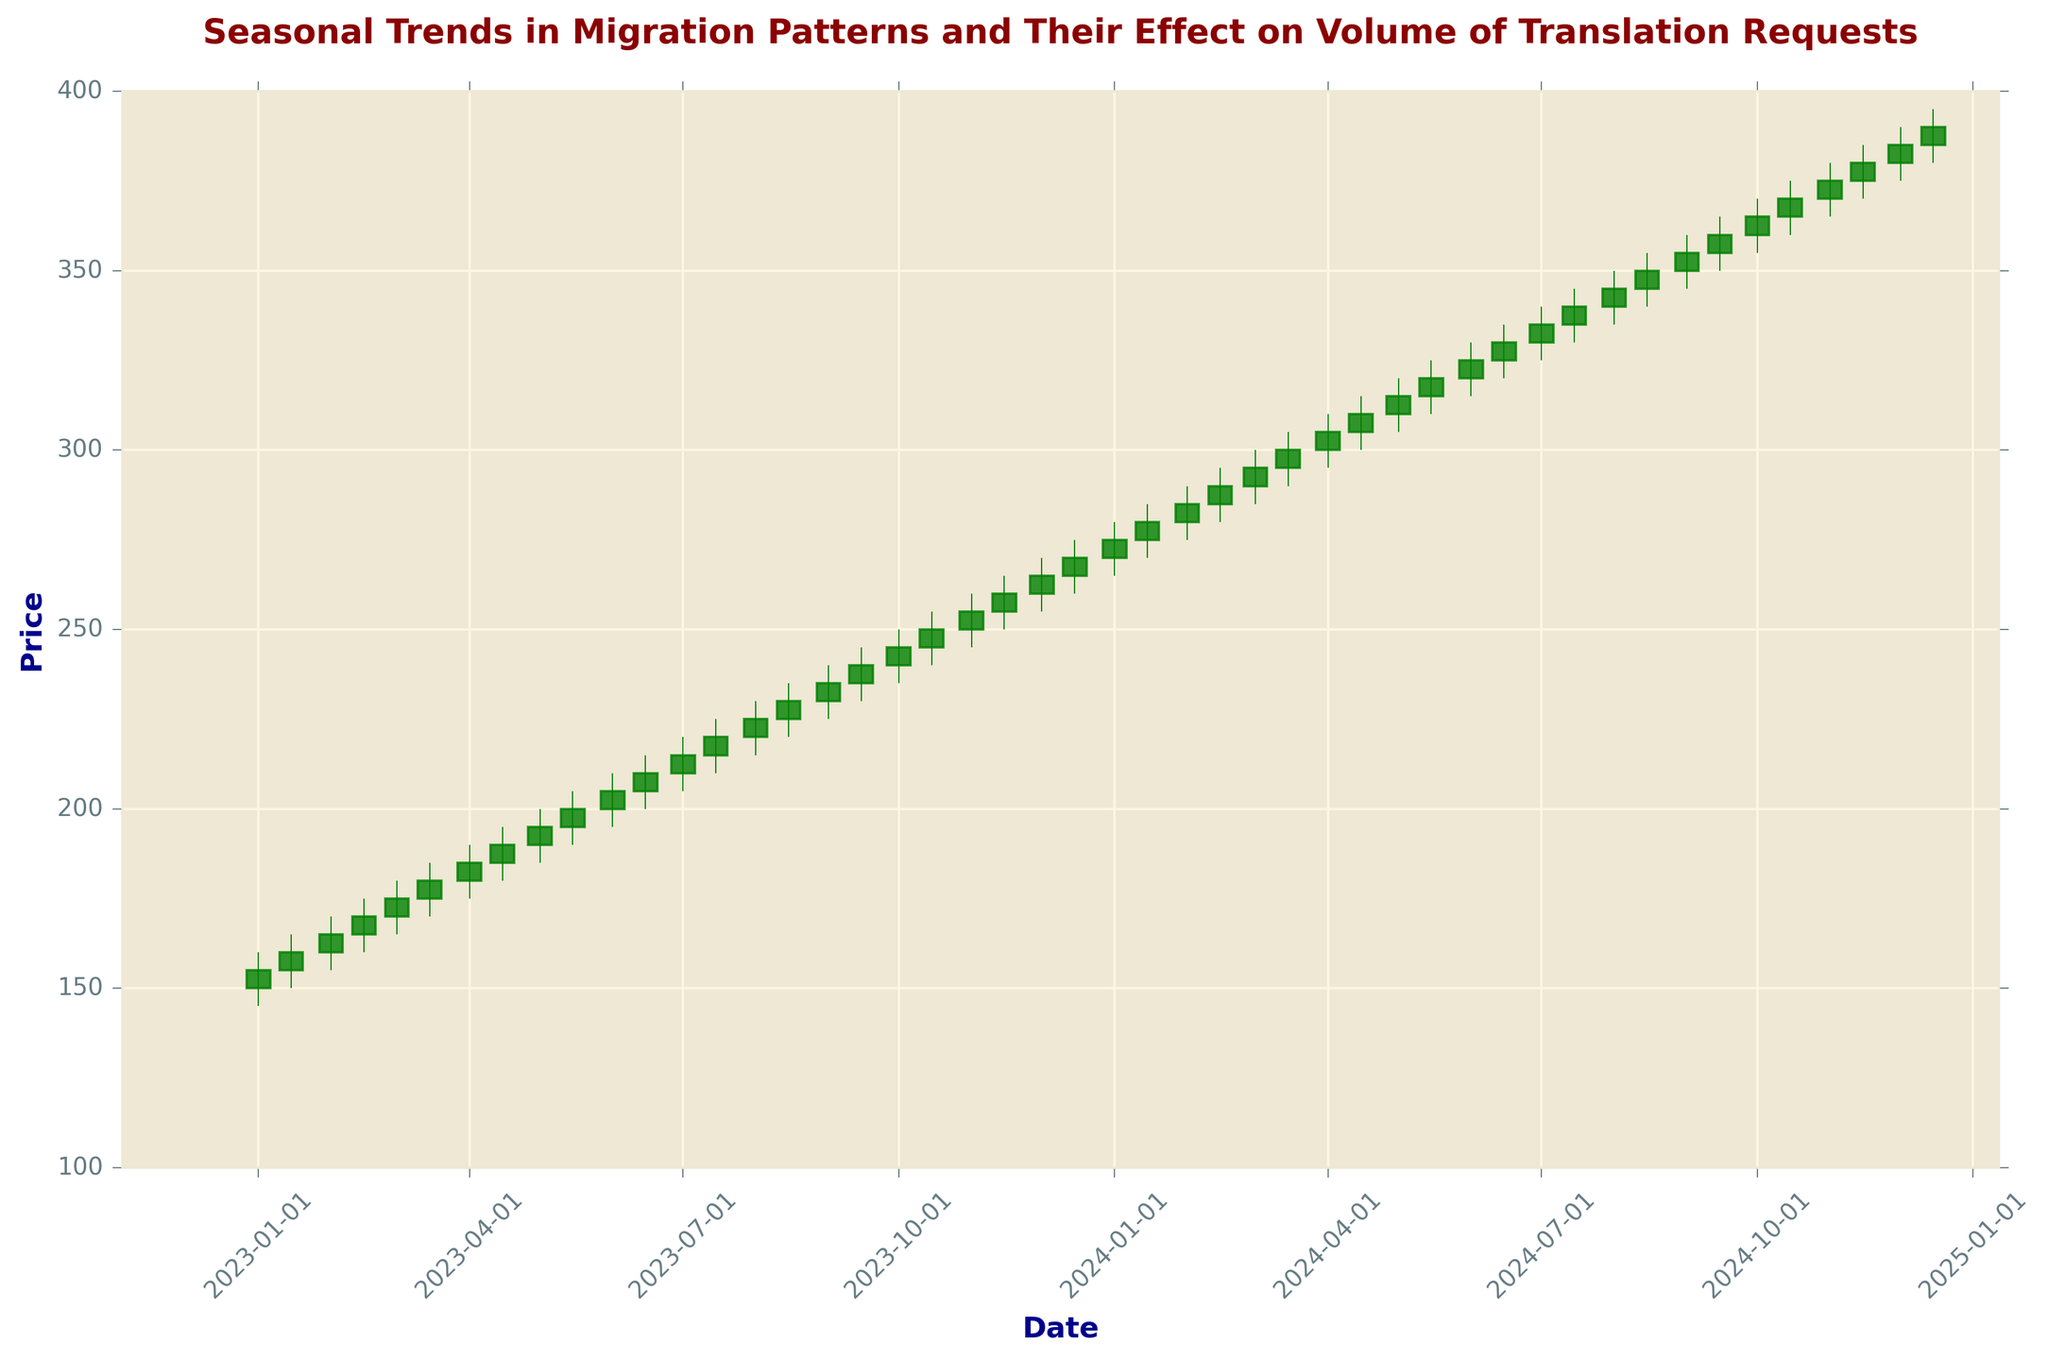Which month has the highest closing price in 2023? To determine the month with the highest closing price, we look at the closing prices throughout the year 2023. The highest closing price is visible in December 2023.
Answer: December Compare the closing prices of January 2023 and August 2023. Which month had a higher closing price? Comparing the closing prices of January 2023 (155) and August 2023 (225). August 2023 has a higher closing price.
Answer: August What is the range (difference between high and low) of prices in March 2024? To find the range for March 2024, subtract the lowest price from the highest price. For March 2024, the high is 305 and the low is 290. The range is 305 - 290 = 15.
Answer: 15 How did the closing price change between May 2023 and May 2024? The closing price in May 2023 was 195, and in May 2024, it was 315. The change in the closing price is 315 - 195 = 120.
Answer: Increased by 120 Which date saw the most significant increase in the closing price compared to the previous date? To find this, we need to look at the differences between consecutive closing prices. The largest increase is from January 15, 2023, to February 1, 2023 (from 160 to 165, which is an increase of 5).
Answer: February 1, 2023 What is the median closing price for the first half of 2024? The first half of 2024 includes January to June. The closing prices are 280, 290, 295, 300, 310, and 320. To find the median, we sort these values (280, 290, 295, 300, 310, 320) and pick the middle value(s). The median is (295 + 300) / 2 = 297.5.
Answer: 297.5 Identify the period where the closing prices were steadily increasing without a decrease. By observing the figure, the period of steady increase without any noticeable decrease can be identified from January 1, 2023, to December 15, 2024. Each closing price is higher than the previous one.
Answer: January 1, 2023, to December 15, 2024 Compare the opening prices of February 2023 and February 2024. Which year had a lower opening price? Comparing the opening prices of February 1, 2023 (160), and February 1, 2024 (280). February 2023 had a lower opening price.
Answer: 2023 How does the price trend from September 2023 to December 2023 compare to the trend from September 2024 to December 2024? For September to December 2023, the closing price increases from 235 to 265. For the same period in 2024, it increases from 365 to 395. Both periods show an increasing trend, but the increase in 2024 is more significant.
Answer: Both increasing, but 2024 more significant What is the average closing price for the year 2023? To find the average closing price for 2023, sum all closing prices and divide by the number of periods: (155 + 160 + 165 + 170 + 175 + 180 + 185 + 190 + 195 + 200 + 205 + 210 + 215 + 220 + 225 + 230 + 235 + 240 + 245 + 250 + 255 + 260 + 265 + 270) / 24 = 207.5.
Answer: 207.5 